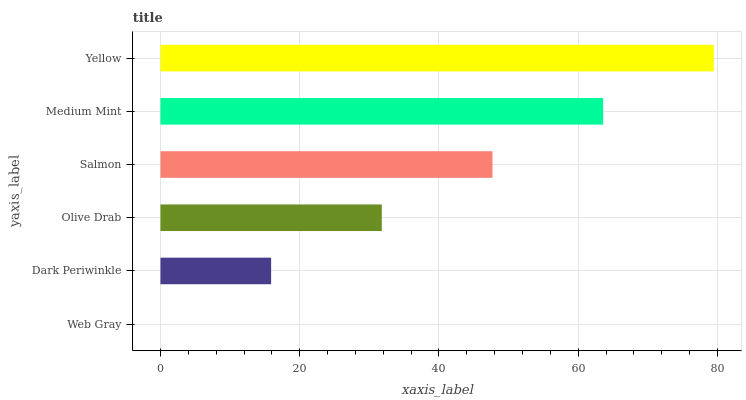Is Web Gray the minimum?
Answer yes or no. Yes. Is Yellow the maximum?
Answer yes or no. Yes. Is Dark Periwinkle the minimum?
Answer yes or no. No. Is Dark Periwinkle the maximum?
Answer yes or no. No. Is Dark Periwinkle greater than Web Gray?
Answer yes or no. Yes. Is Web Gray less than Dark Periwinkle?
Answer yes or no. Yes. Is Web Gray greater than Dark Periwinkle?
Answer yes or no. No. Is Dark Periwinkle less than Web Gray?
Answer yes or no. No. Is Salmon the high median?
Answer yes or no. Yes. Is Olive Drab the low median?
Answer yes or no. Yes. Is Web Gray the high median?
Answer yes or no. No. Is Dark Periwinkle the low median?
Answer yes or no. No. 